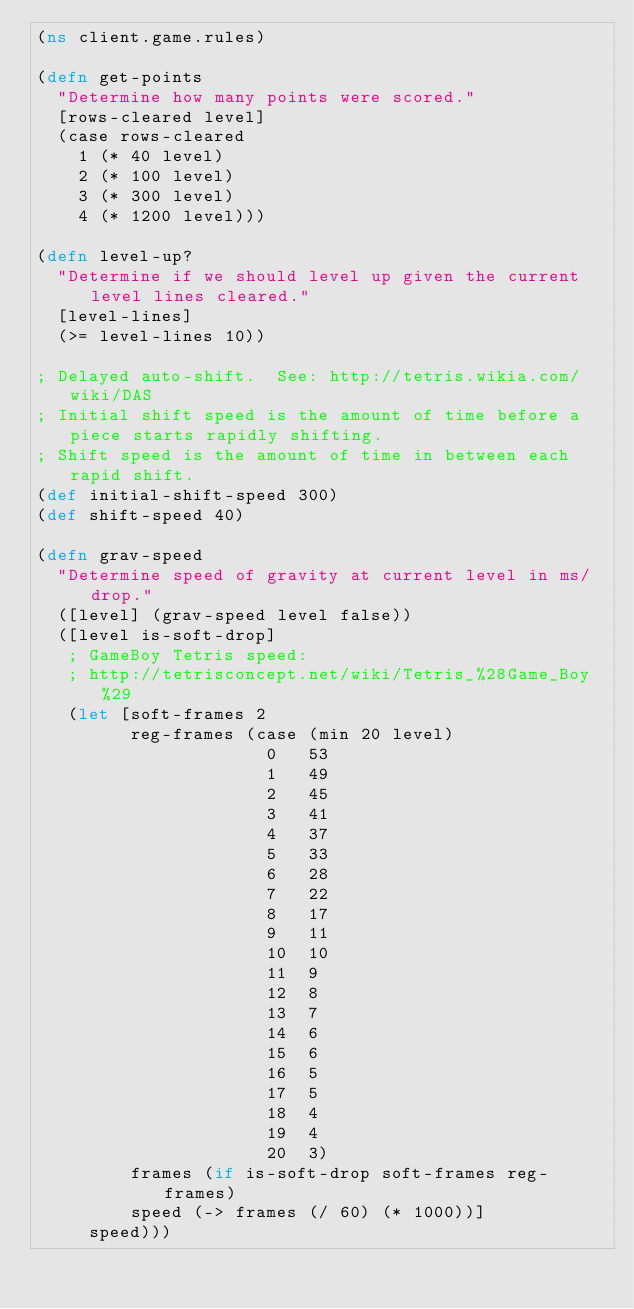<code> <loc_0><loc_0><loc_500><loc_500><_Clojure_>(ns client.game.rules)

(defn get-points
  "Determine how many points were scored."
  [rows-cleared level]
  (case rows-cleared
    1 (* 40 level)
    2 (* 100 level)
    3 (* 300 level)
    4 (* 1200 level)))

(defn level-up?
  "Determine if we should level up given the current level lines cleared."
  [level-lines]
  (>= level-lines 10))

; Delayed auto-shift.  See: http://tetris.wikia.com/wiki/DAS
; Initial shift speed is the amount of time before a piece starts rapidly shifting.
; Shift speed is the amount of time in between each rapid shift.
(def initial-shift-speed 300)
(def shift-speed 40)

(defn grav-speed
  "Determine speed of gravity at current level in ms/drop."
  ([level] (grav-speed level false))
  ([level is-soft-drop]
   ; GameBoy Tetris speed:
   ; http://tetrisconcept.net/wiki/Tetris_%28Game_Boy%29
   (let [soft-frames 2
         reg-frames (case (min 20 level)
                      0 	53
                      1 	49
                      2 	45
                      3 	41
                      4 	37
                      5 	33
                      6 	28
                      7 	22
                      8 	17
                      9 	11
                      10 	10
                      11 	9
                      12 	8
                      13 	7
                      14 	6
                      15 	6
                      16 	5
                      17 	5
                      18 	4
                      19 	4
                      20 	3)
         frames (if is-soft-drop soft-frames reg-frames)
         speed (-> frames (/ 60) (* 1000))]
     speed)))
</code> 